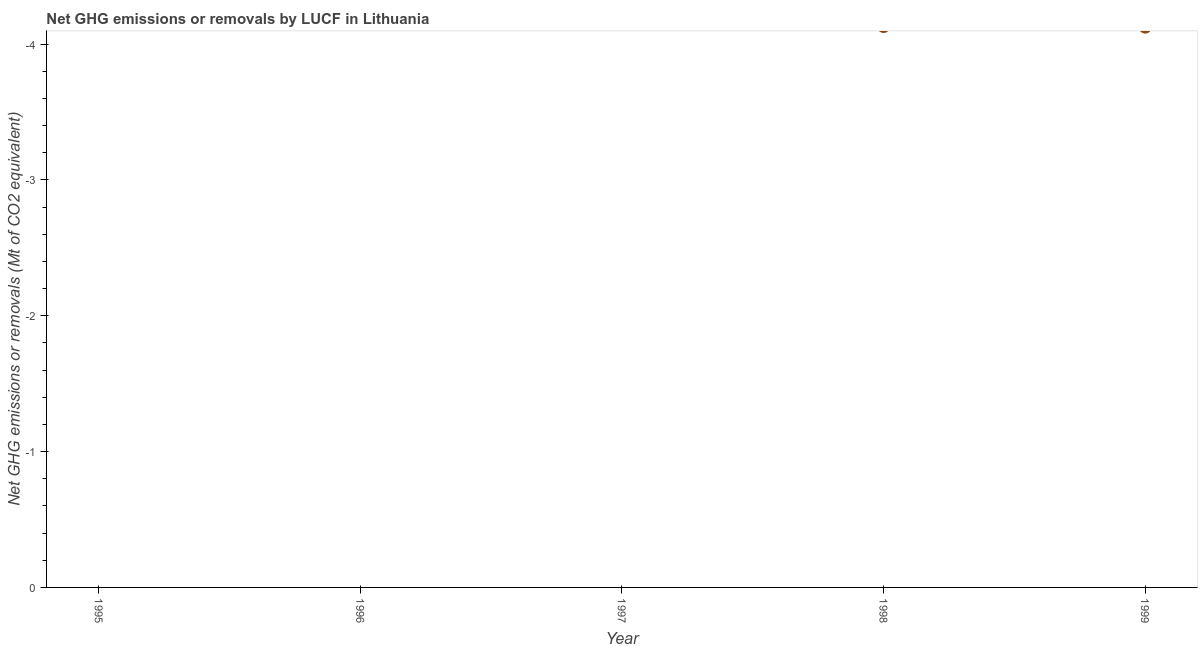What is the ghg net emissions or removals in 1998?
Offer a terse response. 0. Across all years, what is the minimum ghg net emissions or removals?
Make the answer very short. 0. What is the average ghg net emissions or removals per year?
Your answer should be compact. 0. How many years are there in the graph?
Offer a very short reply. 5. What is the difference between two consecutive major ticks on the Y-axis?
Your answer should be compact. 1. Does the graph contain any zero values?
Keep it short and to the point. Yes. What is the title of the graph?
Provide a short and direct response. Net GHG emissions or removals by LUCF in Lithuania. What is the label or title of the X-axis?
Give a very brief answer. Year. What is the label or title of the Y-axis?
Keep it short and to the point. Net GHG emissions or removals (Mt of CO2 equivalent). What is the Net GHG emissions or removals (Mt of CO2 equivalent) in 1996?
Your answer should be compact. 0. What is the Net GHG emissions or removals (Mt of CO2 equivalent) in 1998?
Offer a very short reply. 0. What is the Net GHG emissions or removals (Mt of CO2 equivalent) in 1999?
Keep it short and to the point. 0. 